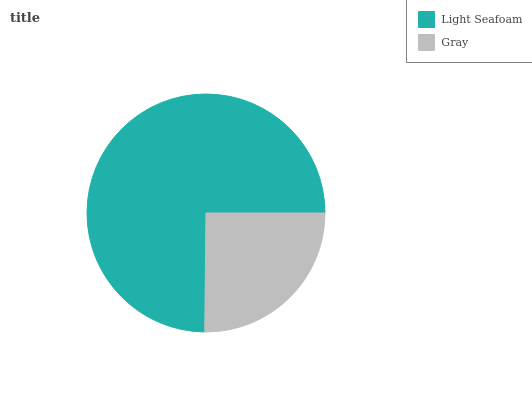Is Gray the minimum?
Answer yes or no. Yes. Is Light Seafoam the maximum?
Answer yes or no. Yes. Is Gray the maximum?
Answer yes or no. No. Is Light Seafoam greater than Gray?
Answer yes or no. Yes. Is Gray less than Light Seafoam?
Answer yes or no. Yes. Is Gray greater than Light Seafoam?
Answer yes or no. No. Is Light Seafoam less than Gray?
Answer yes or no. No. Is Light Seafoam the high median?
Answer yes or no. Yes. Is Gray the low median?
Answer yes or no. Yes. Is Gray the high median?
Answer yes or no. No. Is Light Seafoam the low median?
Answer yes or no. No. 